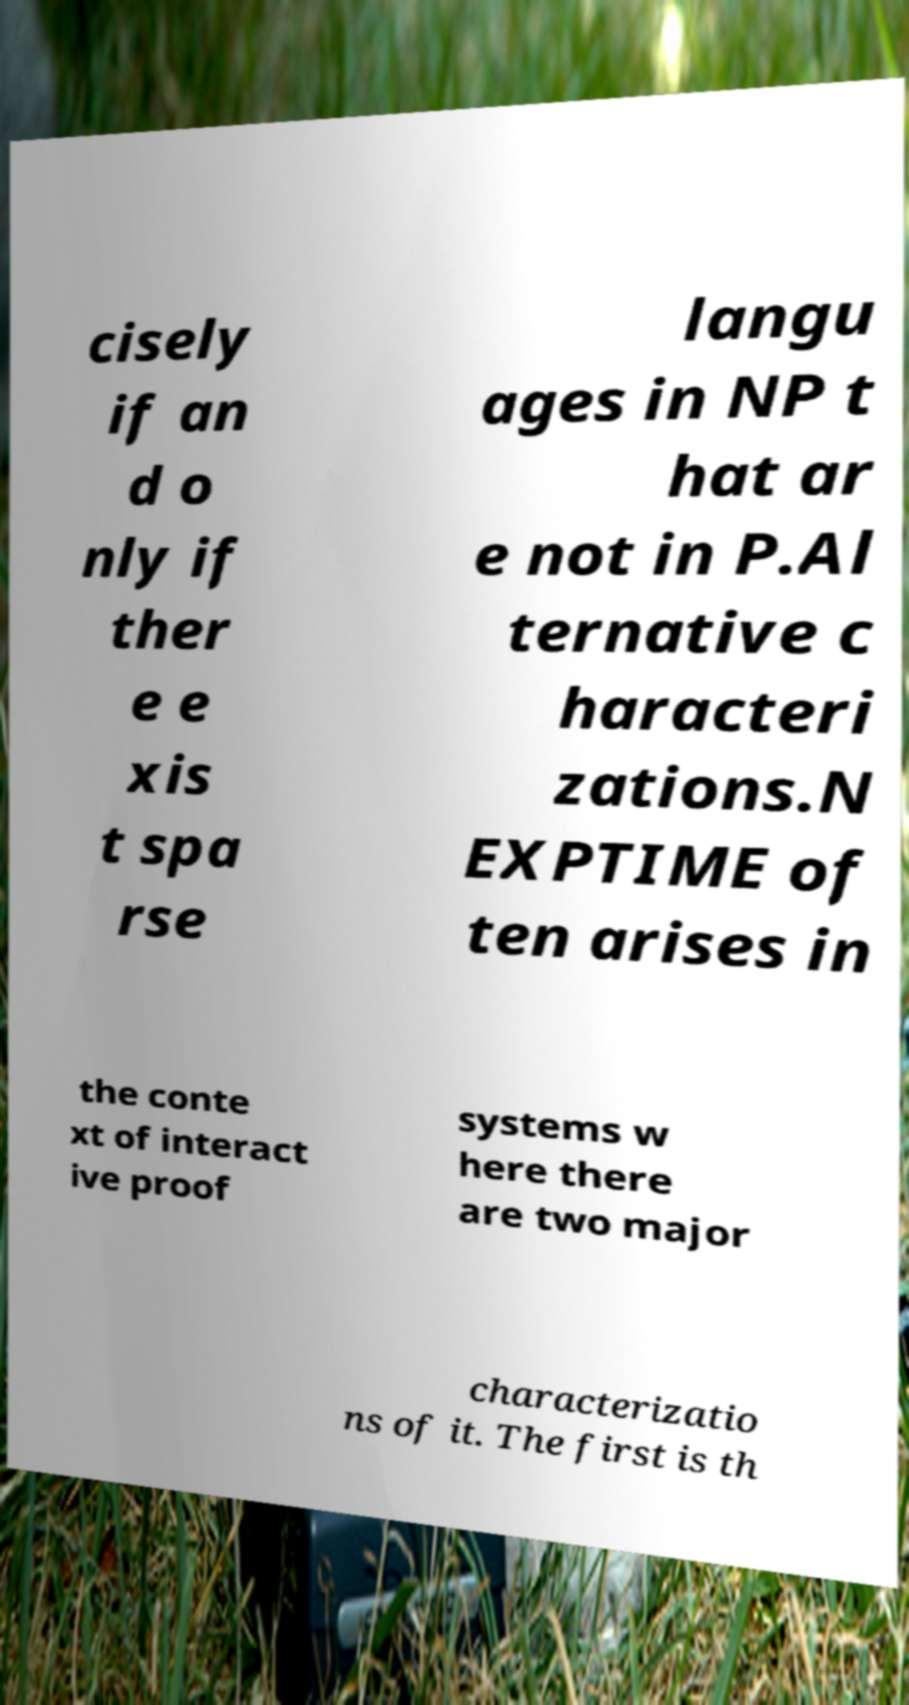Please read and relay the text visible in this image. What does it say? cisely if an d o nly if ther e e xis t spa rse langu ages in NP t hat ar e not in P.Al ternative c haracteri zations.N EXPTIME of ten arises in the conte xt of interact ive proof systems w here there are two major characterizatio ns of it. The first is th 